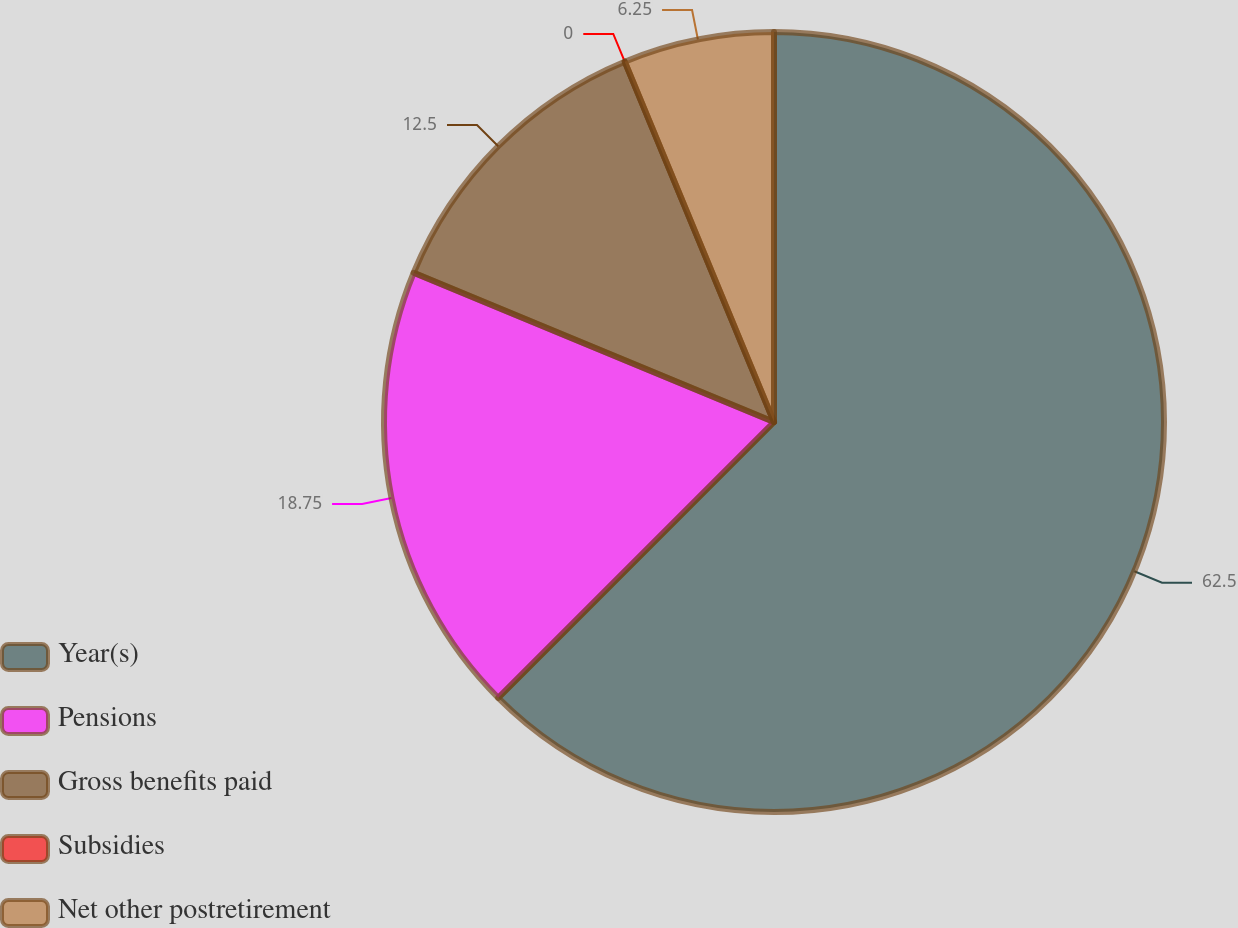Convert chart. <chart><loc_0><loc_0><loc_500><loc_500><pie_chart><fcel>Year(s)<fcel>Pensions<fcel>Gross benefits paid<fcel>Subsidies<fcel>Net other postretirement<nl><fcel>62.5%<fcel>18.75%<fcel>12.5%<fcel>0.0%<fcel>6.25%<nl></chart> 